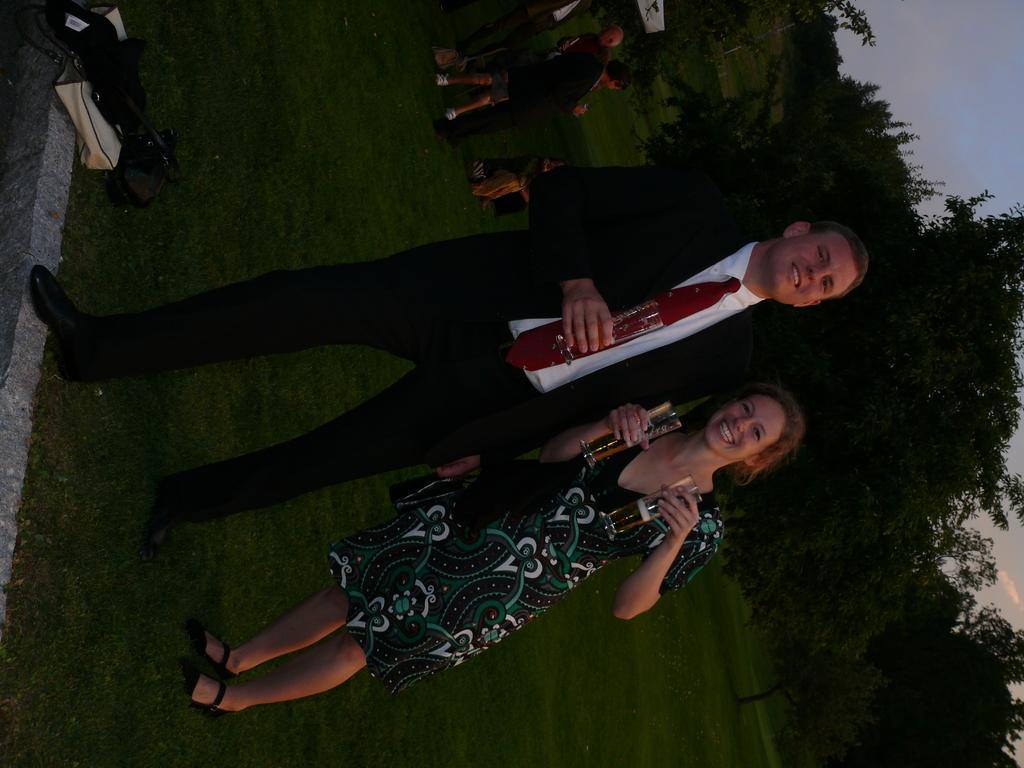How would you summarize this image in a sentence or two? Here a man is standing, he wore a black color coat holding a wine glass beside him, there is a girl who is standing and also holding 2 wine glasses in her hands behind them it's a tree. 